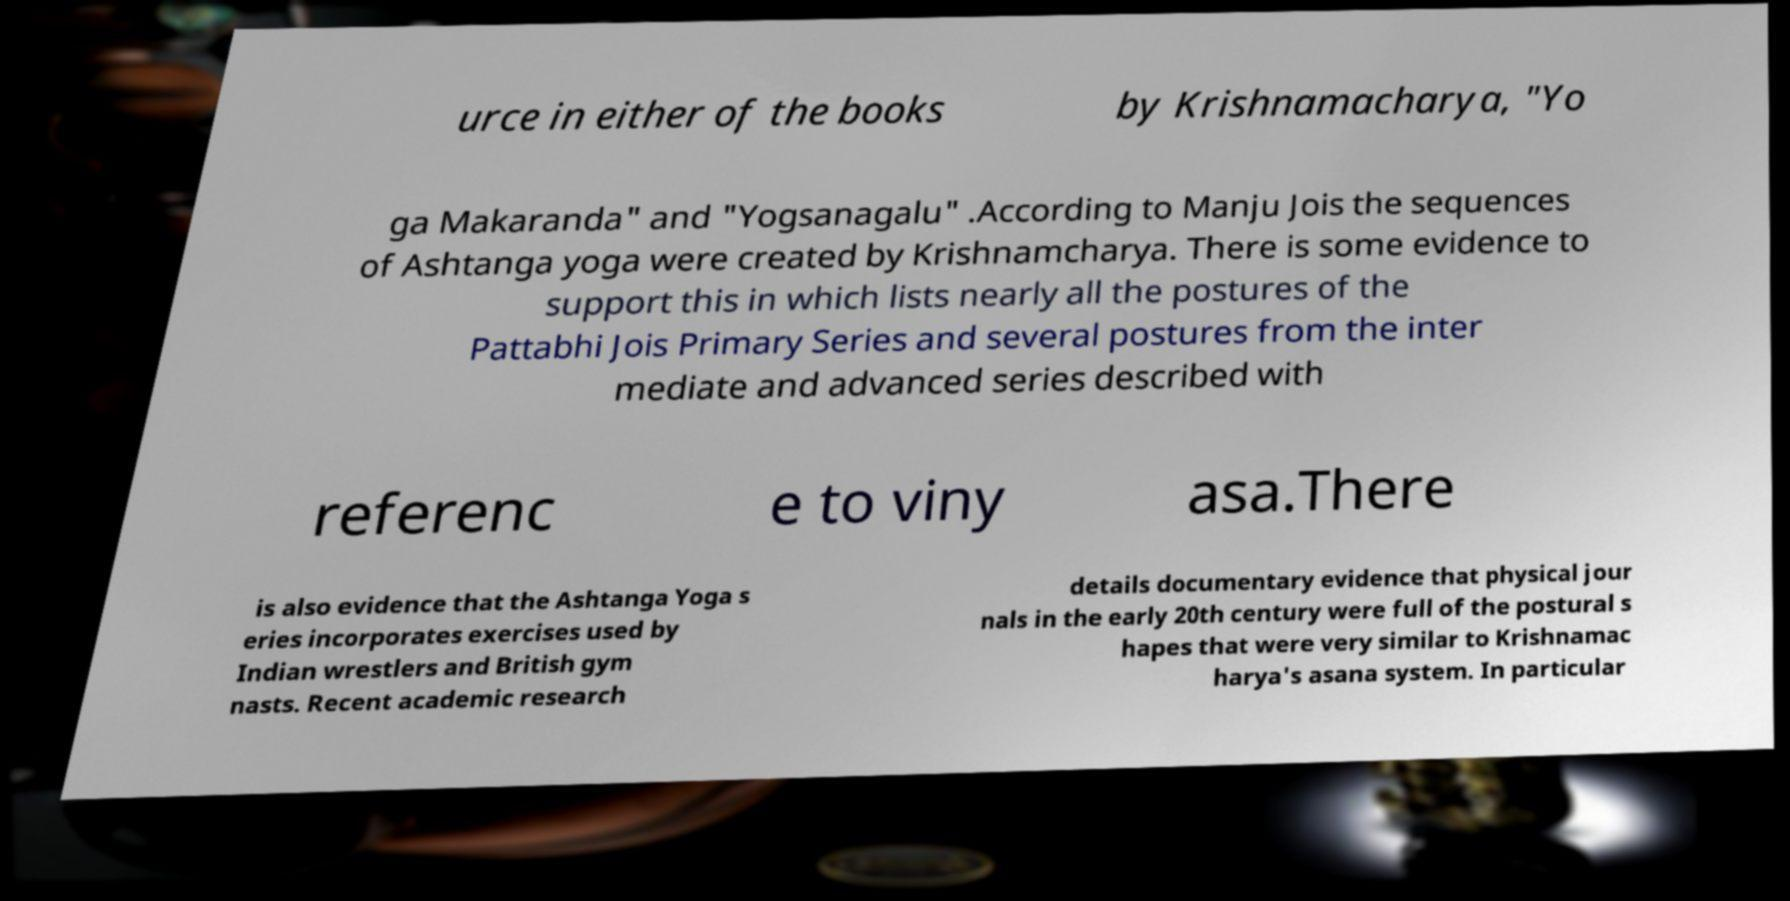What messages or text are displayed in this image? I need them in a readable, typed format. urce in either of the books by Krishnamacharya, "Yo ga Makaranda" and "Yogsanagalu" .According to Manju Jois the sequences of Ashtanga yoga were created by Krishnamcharya. There is some evidence to support this in which lists nearly all the postures of the Pattabhi Jois Primary Series and several postures from the inter mediate and advanced series described with referenc e to viny asa.There is also evidence that the Ashtanga Yoga s eries incorporates exercises used by Indian wrestlers and British gym nasts. Recent academic research details documentary evidence that physical jour nals in the early 20th century were full of the postural s hapes that were very similar to Krishnamac harya's asana system. In particular 